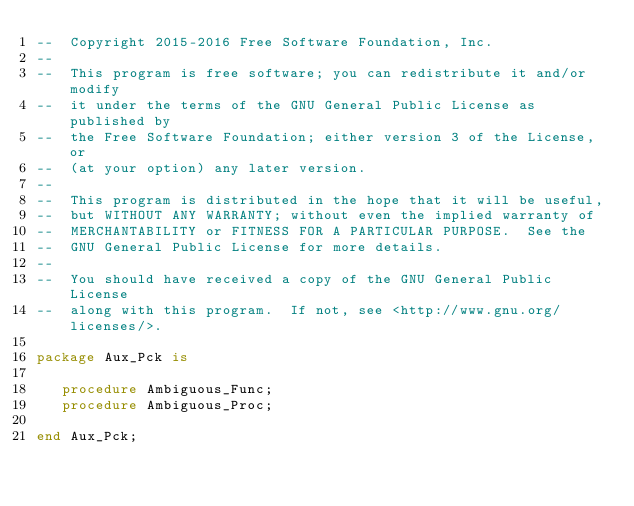Convert code to text. <code><loc_0><loc_0><loc_500><loc_500><_Ada_>--  Copyright 2015-2016 Free Software Foundation, Inc.
--
--  This program is free software; you can redistribute it and/or modify
--  it under the terms of the GNU General Public License as published by
--  the Free Software Foundation; either version 3 of the License, or
--  (at your option) any later version.
--
--  This program is distributed in the hope that it will be useful,
--  but WITHOUT ANY WARRANTY; without even the implied warranty of
--  MERCHANTABILITY or FITNESS FOR A PARTICULAR PURPOSE.  See the
--  GNU General Public License for more details.
--
--  You should have received a copy of the GNU General Public License
--  along with this program.  If not, see <http://www.gnu.org/licenses/>.

package Aux_Pck is

   procedure Ambiguous_Func;
   procedure Ambiguous_Proc;

end Aux_Pck;
</code> 